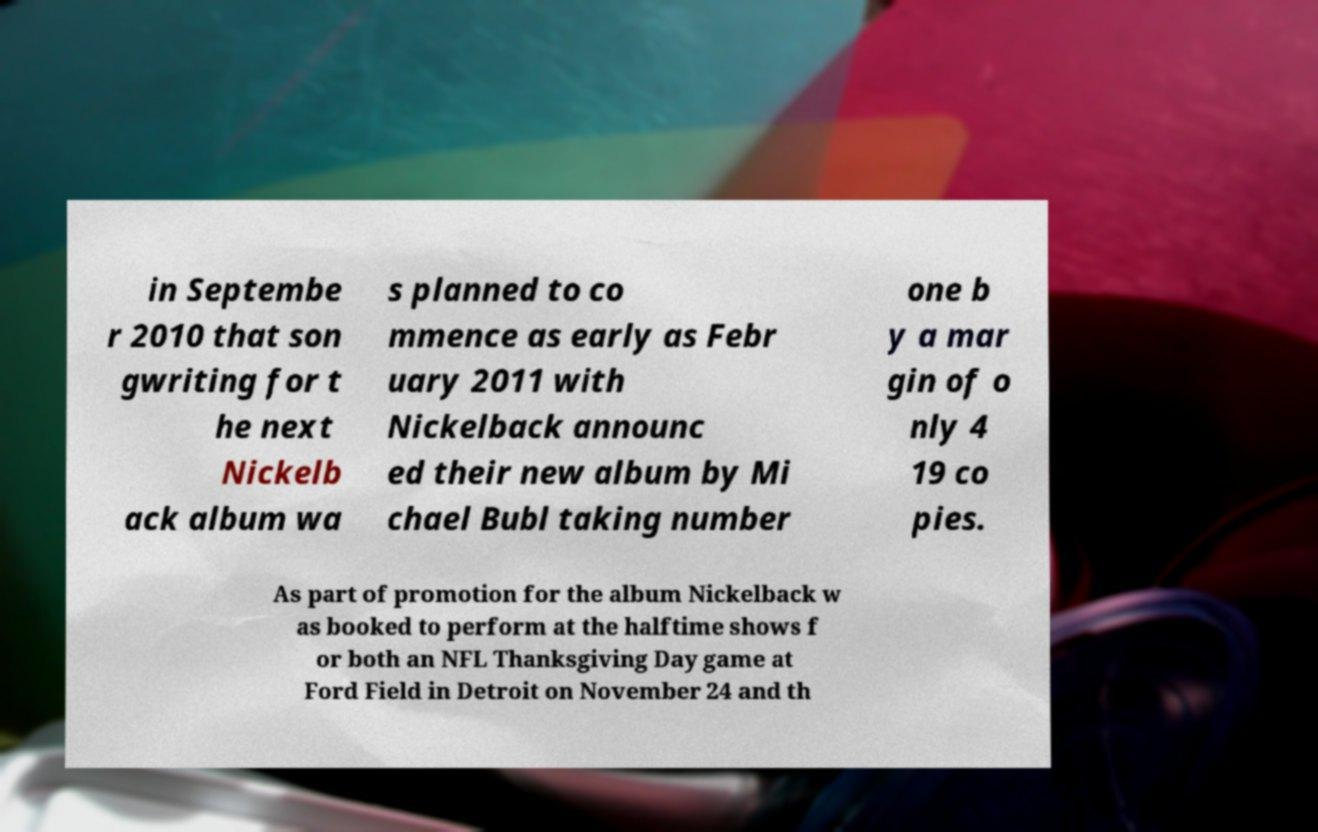Please read and relay the text visible in this image. What does it say? in Septembe r 2010 that son gwriting for t he next Nickelb ack album wa s planned to co mmence as early as Febr uary 2011 with Nickelback announc ed their new album by Mi chael Bubl taking number one b y a mar gin of o nly 4 19 co pies. As part of promotion for the album Nickelback w as booked to perform at the halftime shows f or both an NFL Thanksgiving Day game at Ford Field in Detroit on November 24 and th 